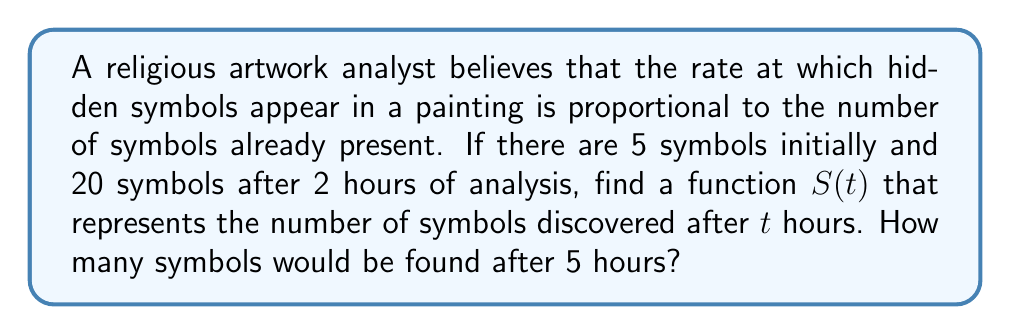Provide a solution to this math problem. Let's approach this step-by-step using a first-order differential equation:

1) The rate of change of symbols is proportional to the number of symbols present:
   $$\frac{dS}{dt} = kS$$
   where $k$ is the proportionality constant.

2) This is a separable differential equation. Separating variables:
   $$\frac{dS}{S} = k dt$$

3) Integrating both sides:
   $$\int \frac{dS}{S} = \int k dt$$
   $$\ln|S| = kt + C$$

4) Solving for $S$:
   $$S(t) = Ce^{kt}$$
   where $C$ is a constant of integration.

5) Using the initial condition $S(0) = 5$:
   $$5 = Ce^{k(0)}$$
   $$C = 5$$

6) Now our equation is:
   $$S(t) = 5e^{kt}$$

7) Using the condition that $S(2) = 20$:
   $$20 = 5e^{2k}$$
   $$4 = e^{2k}$$
   $$\ln 4 = 2k$$
   $$k = \frac{\ln 4}{2}$$

8) Our final equation is:
   $$S(t) = 5e^{(\ln 4/2)t}$$

9) To find the number of symbols after 5 hours, we calculate $S(5)$:
   $$S(5) = 5e^{(\ln 4/2)5} = 5(4^{5/2}) = 5 \cdot 32 = 160$$
Answer: $S(t) = 5e^{(\ln 4/2)t}$; After 5 hours, 160 symbols would be found. 